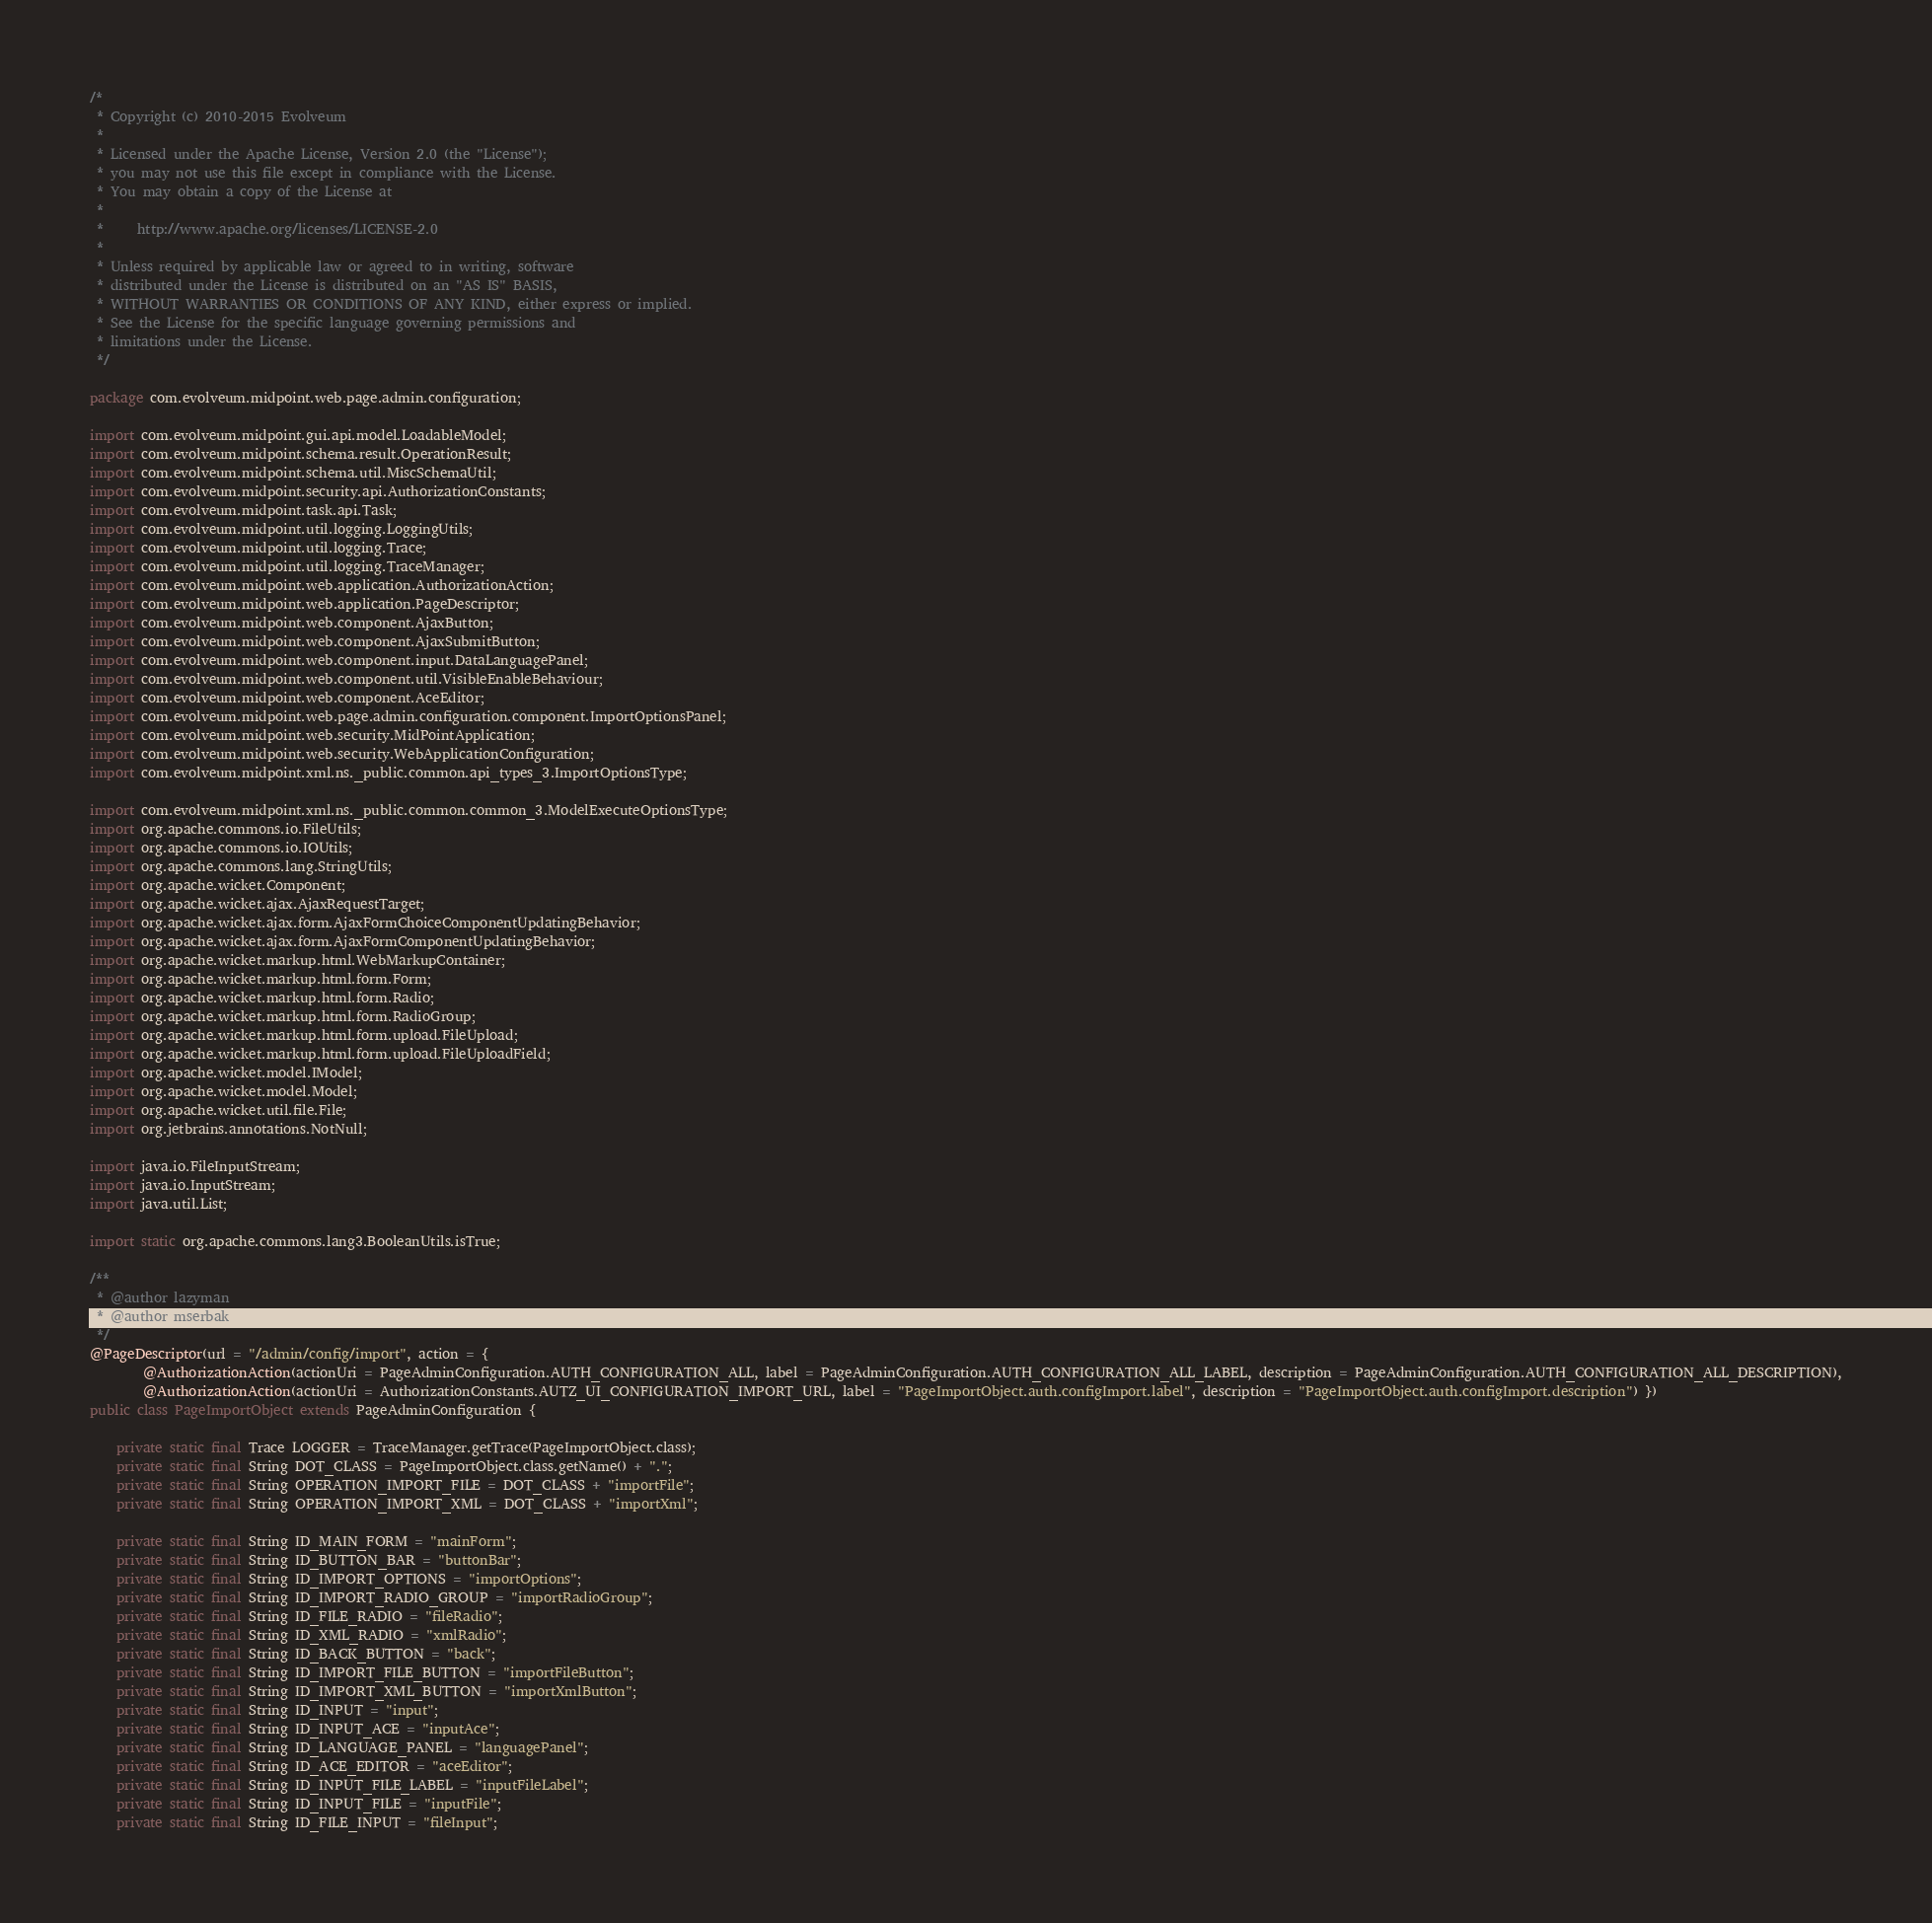Convert code to text. <code><loc_0><loc_0><loc_500><loc_500><_Java_>/*
 * Copyright (c) 2010-2015 Evolveum
 *
 * Licensed under the Apache License, Version 2.0 (the "License");
 * you may not use this file except in compliance with the License.
 * You may obtain a copy of the License at
 *
 *     http://www.apache.org/licenses/LICENSE-2.0
 *
 * Unless required by applicable law or agreed to in writing, software
 * distributed under the License is distributed on an "AS IS" BASIS,
 * WITHOUT WARRANTIES OR CONDITIONS OF ANY KIND, either express or implied.
 * See the License for the specific language governing permissions and
 * limitations under the License.
 */

package com.evolveum.midpoint.web.page.admin.configuration;

import com.evolveum.midpoint.gui.api.model.LoadableModel;
import com.evolveum.midpoint.schema.result.OperationResult;
import com.evolveum.midpoint.schema.util.MiscSchemaUtil;
import com.evolveum.midpoint.security.api.AuthorizationConstants;
import com.evolveum.midpoint.task.api.Task;
import com.evolveum.midpoint.util.logging.LoggingUtils;
import com.evolveum.midpoint.util.logging.Trace;
import com.evolveum.midpoint.util.logging.TraceManager;
import com.evolveum.midpoint.web.application.AuthorizationAction;
import com.evolveum.midpoint.web.application.PageDescriptor;
import com.evolveum.midpoint.web.component.AjaxButton;
import com.evolveum.midpoint.web.component.AjaxSubmitButton;
import com.evolveum.midpoint.web.component.input.DataLanguagePanel;
import com.evolveum.midpoint.web.component.util.VisibleEnableBehaviour;
import com.evolveum.midpoint.web.component.AceEditor;
import com.evolveum.midpoint.web.page.admin.configuration.component.ImportOptionsPanel;
import com.evolveum.midpoint.web.security.MidPointApplication;
import com.evolveum.midpoint.web.security.WebApplicationConfiguration;
import com.evolveum.midpoint.xml.ns._public.common.api_types_3.ImportOptionsType;

import com.evolveum.midpoint.xml.ns._public.common.common_3.ModelExecuteOptionsType;
import org.apache.commons.io.FileUtils;
import org.apache.commons.io.IOUtils;
import org.apache.commons.lang.StringUtils;
import org.apache.wicket.Component;
import org.apache.wicket.ajax.AjaxRequestTarget;
import org.apache.wicket.ajax.form.AjaxFormChoiceComponentUpdatingBehavior;
import org.apache.wicket.ajax.form.AjaxFormComponentUpdatingBehavior;
import org.apache.wicket.markup.html.WebMarkupContainer;
import org.apache.wicket.markup.html.form.Form;
import org.apache.wicket.markup.html.form.Radio;
import org.apache.wicket.markup.html.form.RadioGroup;
import org.apache.wicket.markup.html.form.upload.FileUpload;
import org.apache.wicket.markup.html.form.upload.FileUploadField;
import org.apache.wicket.model.IModel;
import org.apache.wicket.model.Model;
import org.apache.wicket.util.file.File;
import org.jetbrains.annotations.NotNull;

import java.io.FileInputStream;
import java.io.InputStream;
import java.util.List;

import static org.apache.commons.lang3.BooleanUtils.isTrue;

/**
 * @author lazyman
 * @author mserbak
 */
@PageDescriptor(url = "/admin/config/import", action = {
		@AuthorizationAction(actionUri = PageAdminConfiguration.AUTH_CONFIGURATION_ALL, label = PageAdminConfiguration.AUTH_CONFIGURATION_ALL_LABEL, description = PageAdminConfiguration.AUTH_CONFIGURATION_ALL_DESCRIPTION),
		@AuthorizationAction(actionUri = AuthorizationConstants.AUTZ_UI_CONFIGURATION_IMPORT_URL, label = "PageImportObject.auth.configImport.label", description = "PageImportObject.auth.configImport.description") })
public class PageImportObject extends PageAdminConfiguration {

	private static final Trace LOGGER = TraceManager.getTrace(PageImportObject.class);
	private static final String DOT_CLASS = PageImportObject.class.getName() + ".";
	private static final String OPERATION_IMPORT_FILE = DOT_CLASS + "importFile";
	private static final String OPERATION_IMPORT_XML = DOT_CLASS + "importXml";

	private static final String ID_MAIN_FORM = "mainForm";
	private static final String ID_BUTTON_BAR = "buttonBar";
	private static final String ID_IMPORT_OPTIONS = "importOptions";
	private static final String ID_IMPORT_RADIO_GROUP = "importRadioGroup";
	private static final String ID_FILE_RADIO = "fileRadio";
	private static final String ID_XML_RADIO = "xmlRadio";
    private static final String ID_BACK_BUTTON = "back";
	private static final String ID_IMPORT_FILE_BUTTON = "importFileButton";
	private static final String ID_IMPORT_XML_BUTTON = "importXmlButton";
	private static final String ID_INPUT = "input";
	private static final String ID_INPUT_ACE = "inputAce";
	private static final String ID_LANGUAGE_PANEL = "languagePanel";
	private static final String ID_ACE_EDITOR = "aceEditor";
	private static final String ID_INPUT_FILE_LABEL = "inputFileLabel";
	private static final String ID_INPUT_FILE = "inputFile";
	private static final String ID_FILE_INPUT = "fileInput";
</code> 